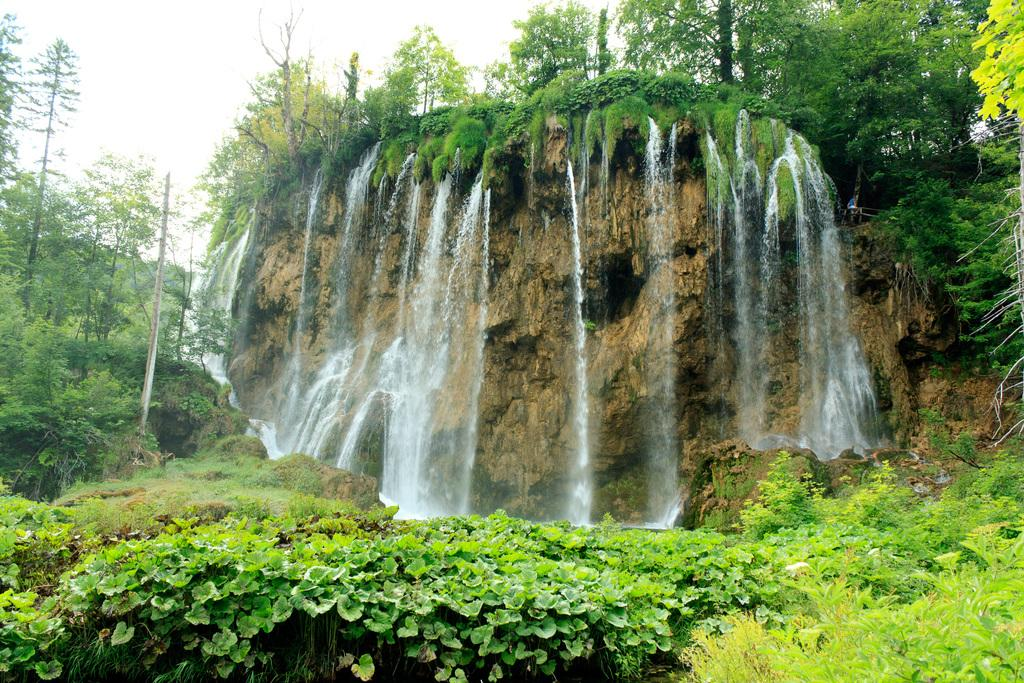What type of natural features can be seen in the image? There are trees and a waterfall in the image. What can be seen in the background of the image? The sky is visible in the background of the image. What direction is the pet walking in the image? There is no pet present in the image, so it is not possible to determine the direction in which a pet might be walking. 